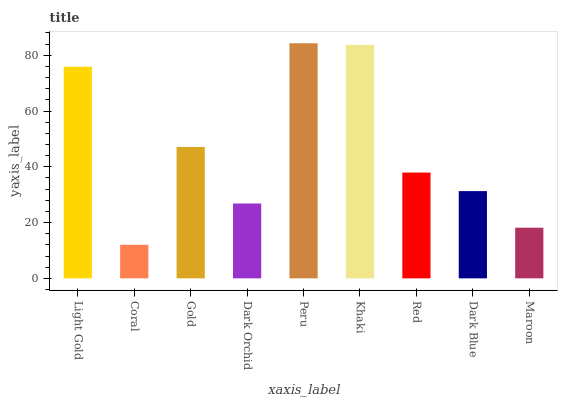Is Coral the minimum?
Answer yes or no. Yes. Is Peru the maximum?
Answer yes or no. Yes. Is Gold the minimum?
Answer yes or no. No. Is Gold the maximum?
Answer yes or no. No. Is Gold greater than Coral?
Answer yes or no. Yes. Is Coral less than Gold?
Answer yes or no. Yes. Is Coral greater than Gold?
Answer yes or no. No. Is Gold less than Coral?
Answer yes or no. No. Is Red the high median?
Answer yes or no. Yes. Is Red the low median?
Answer yes or no. Yes. Is Coral the high median?
Answer yes or no. No. Is Coral the low median?
Answer yes or no. No. 